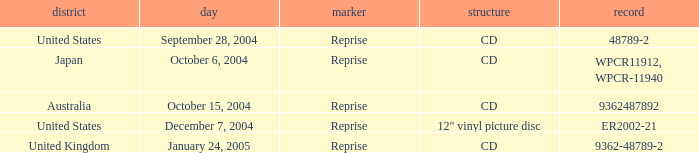Name the date that is a cd September 28, 2004, October 6, 2004, October 15, 2004, January 24, 2005. 